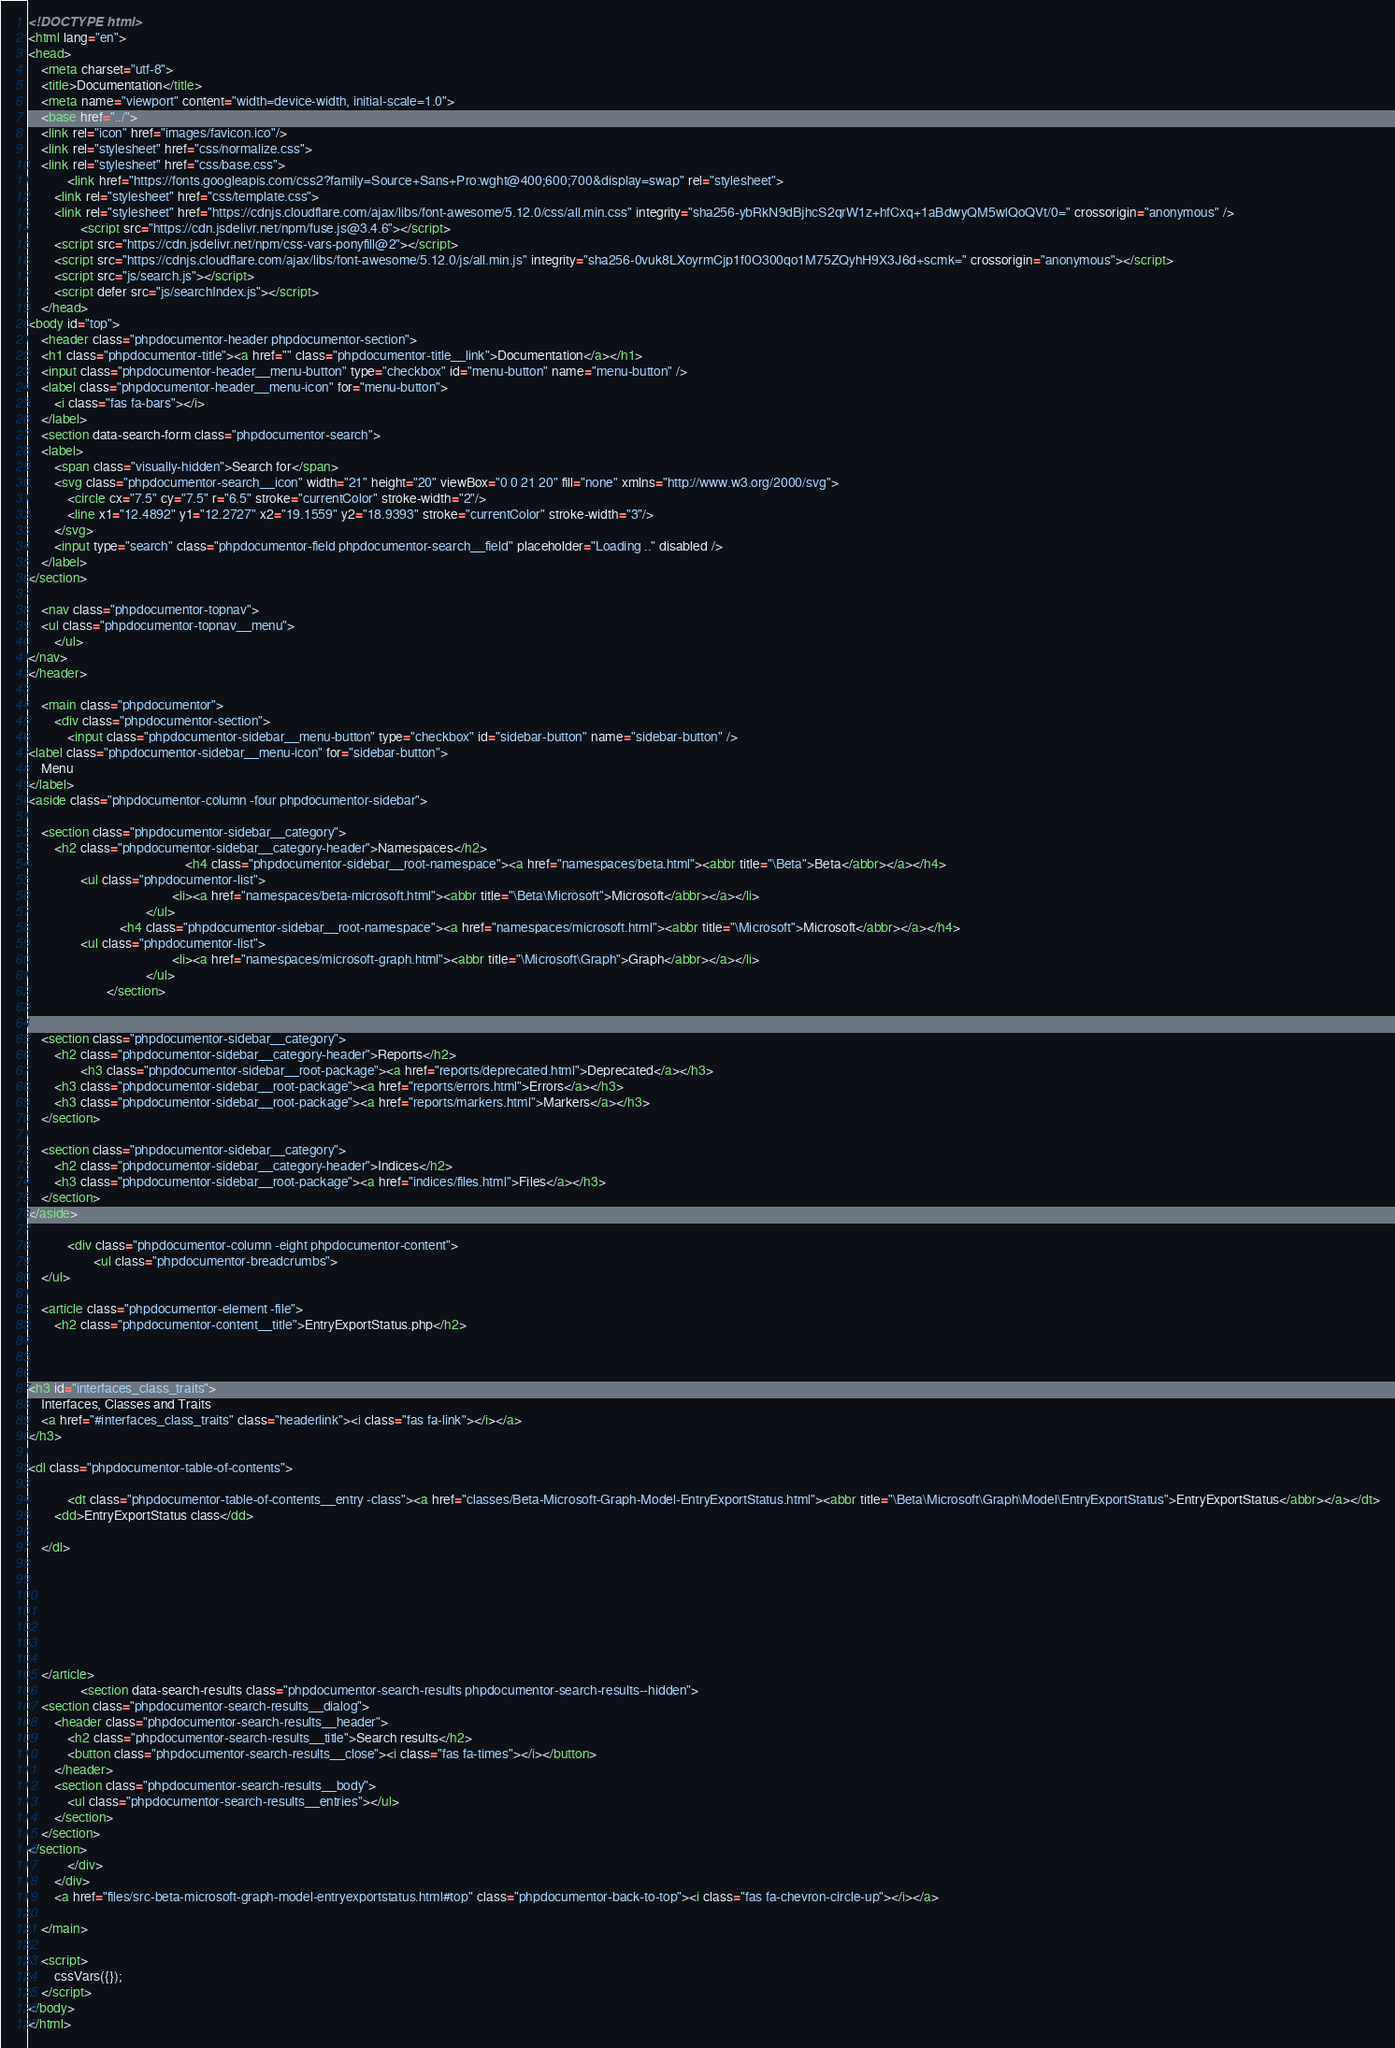Convert code to text. <code><loc_0><loc_0><loc_500><loc_500><_HTML_><!DOCTYPE html>
<html lang="en">
<head>
    <meta charset="utf-8">
    <title>Documentation</title>
    <meta name="viewport" content="width=device-width, initial-scale=1.0">
    <base href="../">
    <link rel="icon" href="images/favicon.ico"/>
    <link rel="stylesheet" href="css/normalize.css">
    <link rel="stylesheet" href="css/base.css">
            <link href="https://fonts.googleapis.com/css2?family=Source+Sans+Pro:wght@400;600;700&display=swap" rel="stylesheet">
        <link rel="stylesheet" href="css/template.css">
        <link rel="stylesheet" href="https://cdnjs.cloudflare.com/ajax/libs/font-awesome/5.12.0/css/all.min.css" integrity="sha256-ybRkN9dBjhcS2qrW1z+hfCxq+1aBdwyQM5wlQoQVt/0=" crossorigin="anonymous" />
                <script src="https://cdn.jsdelivr.net/npm/fuse.js@3.4.6"></script>
        <script src="https://cdn.jsdelivr.net/npm/css-vars-ponyfill@2"></script>
        <script src="https://cdnjs.cloudflare.com/ajax/libs/font-awesome/5.12.0/js/all.min.js" integrity="sha256-0vuk8LXoyrmCjp1f0O300qo1M75ZQyhH9X3J6d+scmk=" crossorigin="anonymous"></script>
        <script src="js/search.js"></script>
        <script defer src="js/searchIndex.js"></script>
    </head>
<body id="top">
    <header class="phpdocumentor-header phpdocumentor-section">
    <h1 class="phpdocumentor-title"><a href="" class="phpdocumentor-title__link">Documentation</a></h1>
    <input class="phpdocumentor-header__menu-button" type="checkbox" id="menu-button" name="menu-button" />
    <label class="phpdocumentor-header__menu-icon" for="menu-button">
        <i class="fas fa-bars"></i>
    </label>
    <section data-search-form class="phpdocumentor-search">
    <label>
        <span class="visually-hidden">Search for</span>
        <svg class="phpdocumentor-search__icon" width="21" height="20" viewBox="0 0 21 20" fill="none" xmlns="http://www.w3.org/2000/svg">
            <circle cx="7.5" cy="7.5" r="6.5" stroke="currentColor" stroke-width="2"/>
            <line x1="12.4892" y1="12.2727" x2="19.1559" y2="18.9393" stroke="currentColor" stroke-width="3"/>
        </svg>
        <input type="search" class="phpdocumentor-field phpdocumentor-search__field" placeholder="Loading .." disabled />
    </label>
</section>

    <nav class="phpdocumentor-topnav">
    <ul class="phpdocumentor-topnav__menu">
        </ul>
</nav>
</header>

    <main class="phpdocumentor">
        <div class="phpdocumentor-section">
            <input class="phpdocumentor-sidebar__menu-button" type="checkbox" id="sidebar-button" name="sidebar-button" />
<label class="phpdocumentor-sidebar__menu-icon" for="sidebar-button">
    Menu
</label>
<aside class="phpdocumentor-column -four phpdocumentor-sidebar">
    
    <section class="phpdocumentor-sidebar__category">
        <h2 class="phpdocumentor-sidebar__category-header">Namespaces</h2>
                                                <h4 class="phpdocumentor-sidebar__root-namespace"><a href="namespaces/beta.html"><abbr title="\Beta">Beta</abbr></a></h4>
                <ul class="phpdocumentor-list">
                                            <li><a href="namespaces/beta-microsoft.html"><abbr title="\Beta\Microsoft">Microsoft</abbr></a></li>
                                    </ul>
                            <h4 class="phpdocumentor-sidebar__root-namespace"><a href="namespaces/microsoft.html"><abbr title="\Microsoft">Microsoft</abbr></a></h4>
                <ul class="phpdocumentor-list">
                                            <li><a href="namespaces/microsoft-graph.html"><abbr title="\Microsoft\Graph">Graph</abbr></a></li>
                                    </ul>
                        </section>

    
    <section class="phpdocumentor-sidebar__category">
        <h2 class="phpdocumentor-sidebar__category-header">Reports</h2>
                <h3 class="phpdocumentor-sidebar__root-package"><a href="reports/deprecated.html">Deprecated</a></h3>
        <h3 class="phpdocumentor-sidebar__root-package"><a href="reports/errors.html">Errors</a></h3>
        <h3 class="phpdocumentor-sidebar__root-package"><a href="reports/markers.html">Markers</a></h3>
    </section>

    <section class="phpdocumentor-sidebar__category">
        <h2 class="phpdocumentor-sidebar__category-header">Indices</h2>
        <h3 class="phpdocumentor-sidebar__root-package"><a href="indices/files.html">Files</a></h3>
    </section>
</aside>

            <div class="phpdocumentor-column -eight phpdocumentor-content">
                    <ul class="phpdocumentor-breadcrumbs">
    </ul>

    <article class="phpdocumentor-element -file">
        <h2 class="phpdocumentor-content__title">EntryExportStatus.php</h2>

        

<h3 id="interfaces_class_traits">
    Interfaces, Classes and Traits
    <a href="#interfaces_class_traits" class="headerlink"><i class="fas fa-link"></i></a>
</h3>

<dl class="phpdocumentor-table-of-contents">
    
            <dt class="phpdocumentor-table-of-contents__entry -class"><a href="classes/Beta-Microsoft-Graph-Model-EntryExportStatus.html"><abbr title="\Beta\Microsoft\Graph\Model\EntryExportStatus">EntryExportStatus</abbr></a></dt>
        <dd>EntryExportStatus class</dd>
    
    </dl>




        

        
    </article>
                <section data-search-results class="phpdocumentor-search-results phpdocumentor-search-results--hidden">
    <section class="phpdocumentor-search-results__dialog">
        <header class="phpdocumentor-search-results__header">
            <h2 class="phpdocumentor-search-results__title">Search results</h2>
            <button class="phpdocumentor-search-results__close"><i class="fas fa-times"></i></button>
        </header>
        <section class="phpdocumentor-search-results__body">
            <ul class="phpdocumentor-search-results__entries"></ul>
        </section>
    </section>
</section>
            </div>
        </div>
        <a href="files/src-beta-microsoft-graph-model-entryexportstatus.html#top" class="phpdocumentor-back-to-top"><i class="fas fa-chevron-circle-up"></i></a>

    </main>

    <script>
        cssVars({});
    </script>
</body>
</html>
</code> 